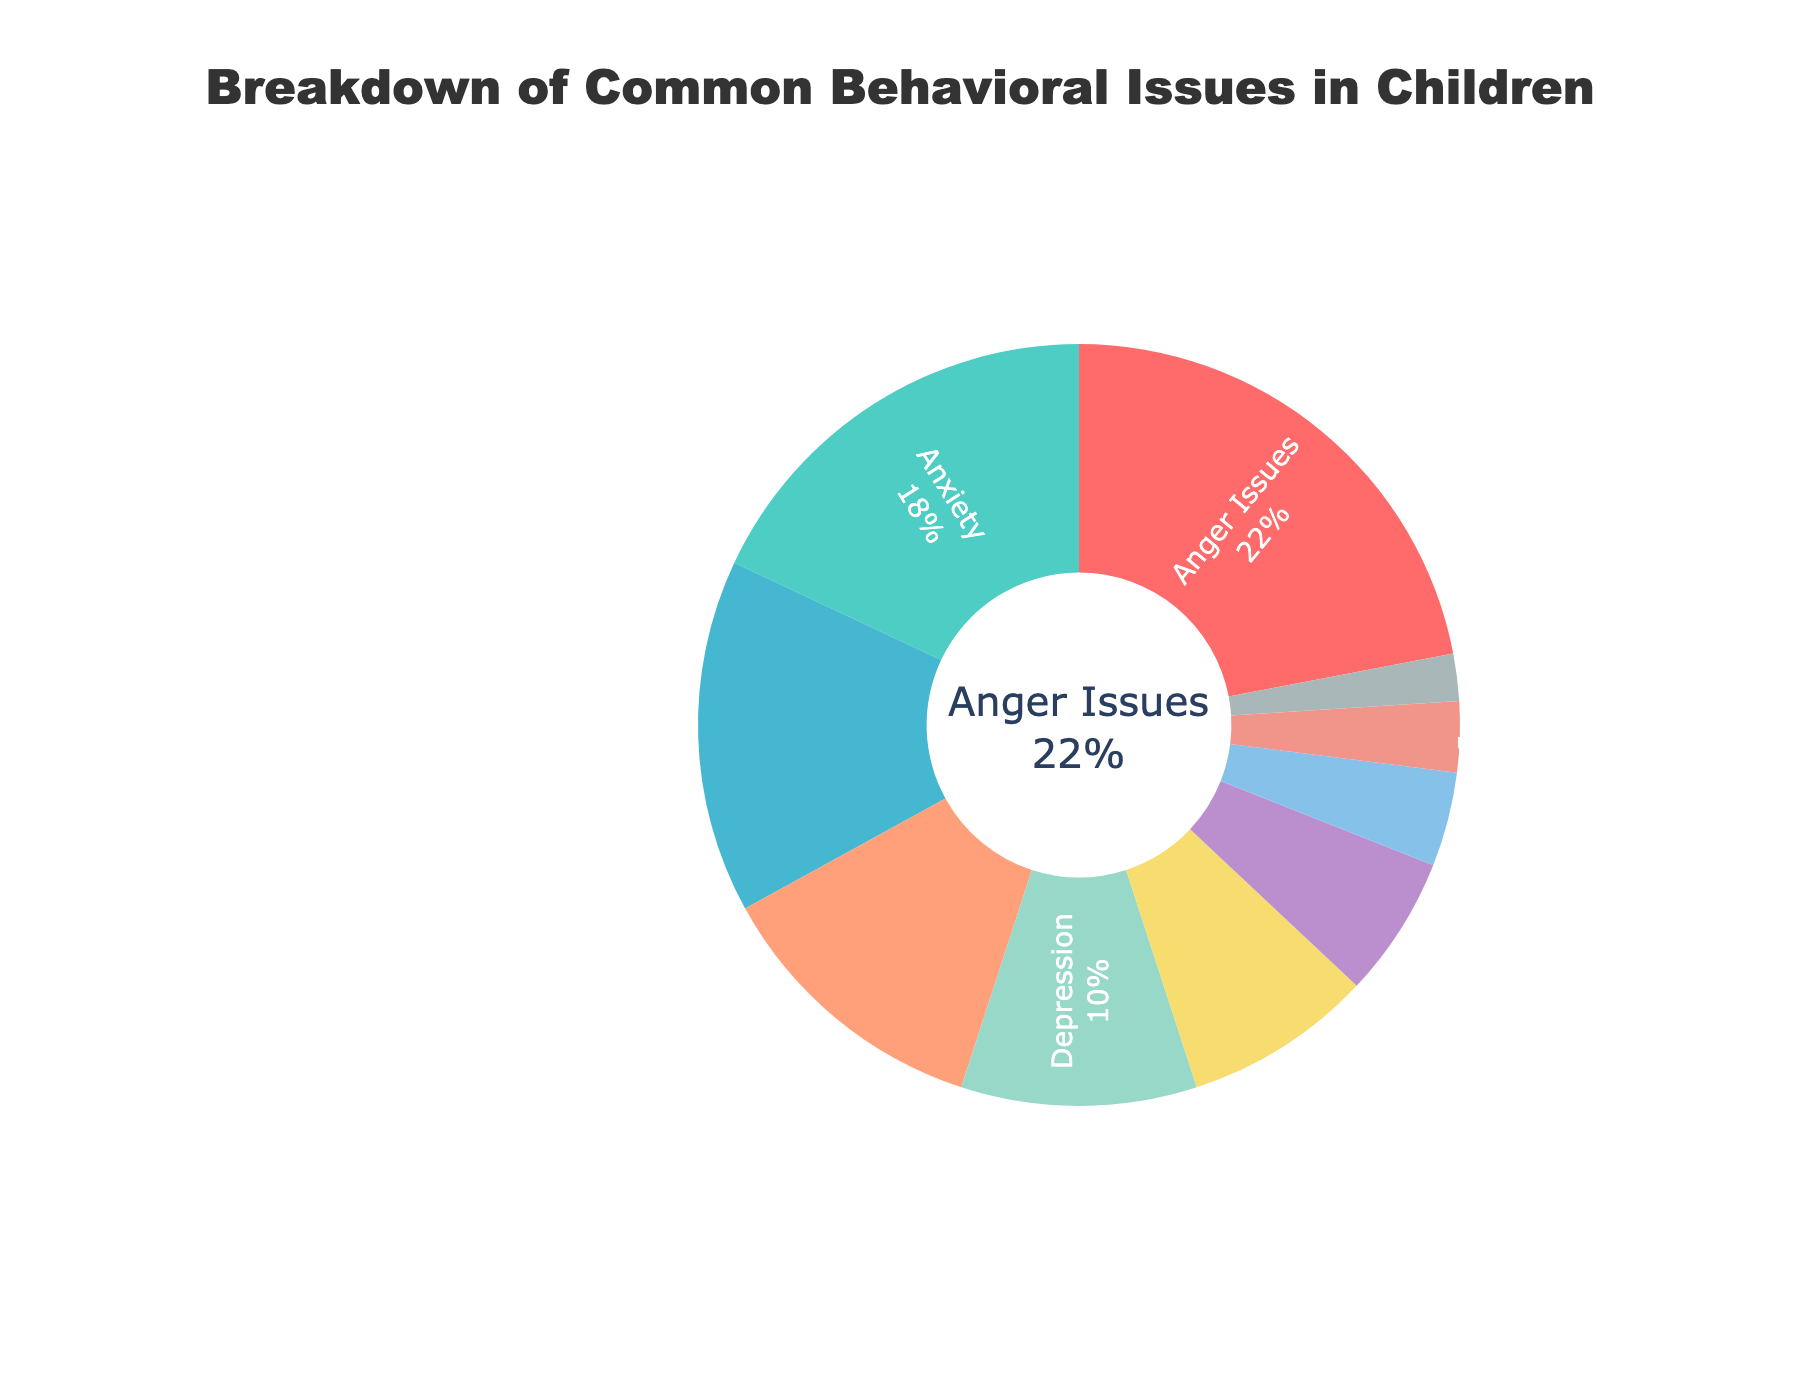what is the largest percentage of a single behavioral issue in the pie chart? The largest percentage is found by comparing all segment percentages. Anger Issues have the highest percentage at 22%.
Answer: 22% which behavioral issue has a percentage equal to half that of anxiety? To find this, we need to see what is half of 18% (Anxiety). Half of 18% is 9%. Hence, no category matches exactly, but Learning Disabilities with 8% is the closest match.
Answer: None What are the combined percentages of ADHD, ODD, and Autism Spectrum Disorder? Add the percentages of ADHD (15%), ODD (12%), and Autism Spectrum Disorder (6%). The combined value is 15% + 12% + 6% = 33%.
Answer: 33% how do anger issues compare to depression in percentage? Anger Issues have 22%, while Depression has 10%. So, Anger Issues are more common than Depression.
Answer: Anger Issues are more common which category is represented by the green segment? When we examine the pie chart, the green segment corresponds to Anxiety which has a percentage of 18%.
Answer: Anxiety how much more common are anger issues than sleep disorders? Anger Issues have a percentage of 22%, while Sleep Disorders have 4%. The difference is 22% - 4% = 18%.
Answer: 18% what is the sum of the percentages for eating disorders and substance abuse? Add the percentages for Eating Disorders (3%) and Substance Abuse (2%). The sum is 3% + 2% = 5%.
Answer: 5% in terms of percentage, which behavioral issues occur less frequently than learning disabilities? Learning Disabilities have a percentage of 8%. The categories with less frequency are Autism Spectrum Disorder (6%), Sleep Disorders (4%), Eating Disorders (3%), and Substance Abuse (2%).
Answer: Autism Spectrum Disorder, Sleep Disorders, Eating Disorders, Substance Abuse if both ADHD and ODD percentages are combined, how do they compare against anger issues? ADHD has 15% and ODD has 12%. Combined, they have 15% + 12% = 27%. Compared to Anger Issues which has 22%, the combined value is higher.
Answer: higher how many behavioral issues have a percentage higher than 10%? By checking each category: Anger Issues (22%), Anxiety (18%), ADHD (15%), ODD (12%) all have percentages higher than 10%. In total, there are 4 behavioral issues.
Answer: 4 